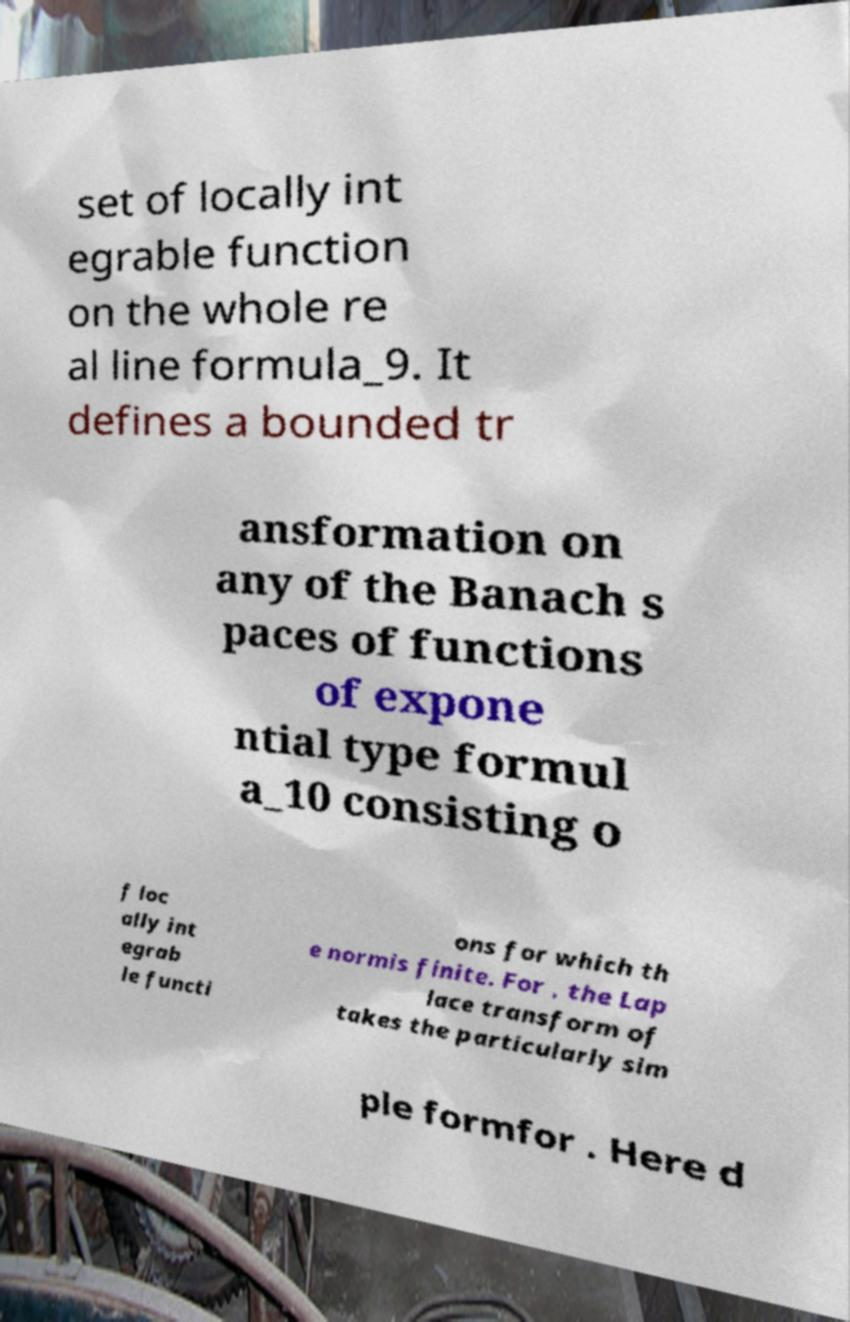Please identify and transcribe the text found in this image. set of locally int egrable function on the whole re al line formula_9. It defines a bounded tr ansformation on any of the Banach s paces of functions of expone ntial type formul a_10 consisting o f loc ally int egrab le functi ons for which th e normis finite. For , the Lap lace transform of takes the particularly sim ple formfor . Here d 